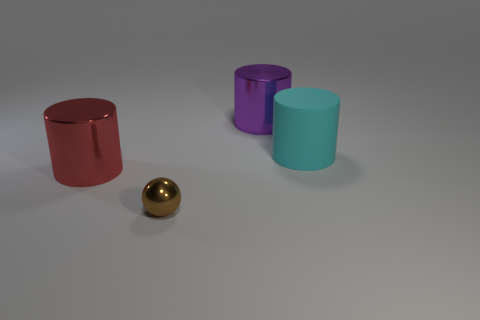Subtract all rubber cylinders. How many cylinders are left? 2 Subtract all cyan cylinders. How many cylinders are left? 2 Subtract 3 cylinders. How many cylinders are left? 0 Add 4 brown shiny blocks. How many objects exist? 8 Subtract all cylinders. How many objects are left? 1 Add 2 rubber cylinders. How many rubber cylinders are left? 3 Add 4 tiny green balls. How many tiny green balls exist? 4 Subtract 0 yellow cylinders. How many objects are left? 4 Subtract all cyan cylinders. Subtract all brown cubes. How many cylinders are left? 2 Subtract all tiny gray matte cylinders. Subtract all red things. How many objects are left? 3 